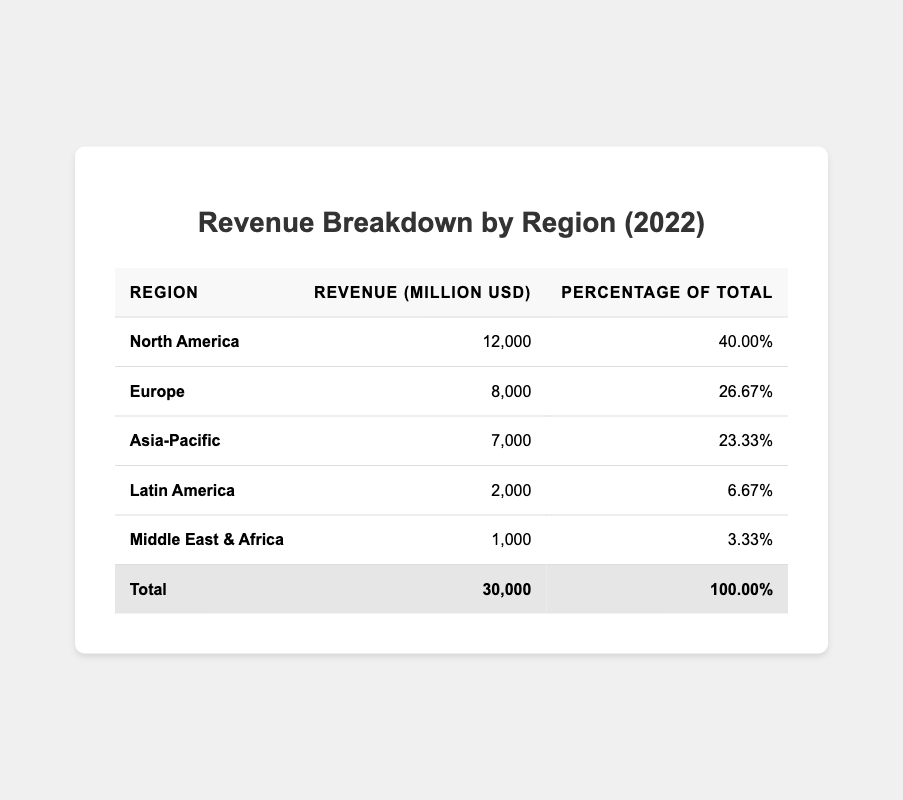What is the total revenue for the corporation in 2022? The total revenue is provided at the bottom of the table, indicating a total of 30,000 million USD for the year 2022.
Answer: 30,000 million USD Which region contributed the highest revenue? By examining the revenue figures in the table, North America has the highest revenue at 12,000 million USD.
Answer: North America What percentage of the total revenue did Asia-Pacific generate? The table shows that Asia-Pacific's revenue is 7,000 million USD, which corresponds to 23.33% of the total revenue.
Answer: 23.33% How much more revenue did Europe generate compared to Latin America? Europe generated 8,000 million USD, while Latin America generated 2,000 million USD. The difference is 8,000 - 2,000 = 6,000 million USD.
Answer: 6,000 million USD What is the combined revenue from Latin America and the Middle East & Africa? Latin America generated 2,000 million USD and the Middle East & Africa generated 1,000 million USD. The total combined revenue is 2,000 + 1,000 = 3,000 million USD.
Answer: 3,000 million USD Is the revenue from North America greater than the combined revenue of Europe and Asia-Pacific? North America's revenue is 12,000 million USD. Combined, Europe and Asia-Pacific have 8,000 + 7,000 = 15,000 million USD. Since 12,000 is less than 15,000, the statement is false.
Answer: No What percentage of total revenue is contributed by regions other than North America? North America contributes 40%. Therefore, the combined percentage of the other regions is 100% - 40% = 60%.
Answer: 60% If the total revenue is equally divided among the five regions, how much would each region receive? Total revenue of 30,000 million USD divided by 5 regions equals 30,000 / 5 = 6,000 million USD for each region.
Answer: 6,000 million USD What is the difference in revenue between the highest and lowest revenue-generating regions? The highest revenue-generating region is North America with 12,000 million USD, and the lowest is Middle East & Africa with 1,000 million USD. The difference is 12,000 - 1,000 = 11,000 million USD.
Answer: 11,000 million USD What fraction of the total revenue does Europe represent? Europe’s revenue is 8,000 million USD, and the total revenue is 30,000 million USD. Thus, the fraction is 8,000 / 30,000, which simplifies to 4/15.
Answer: 4/15 